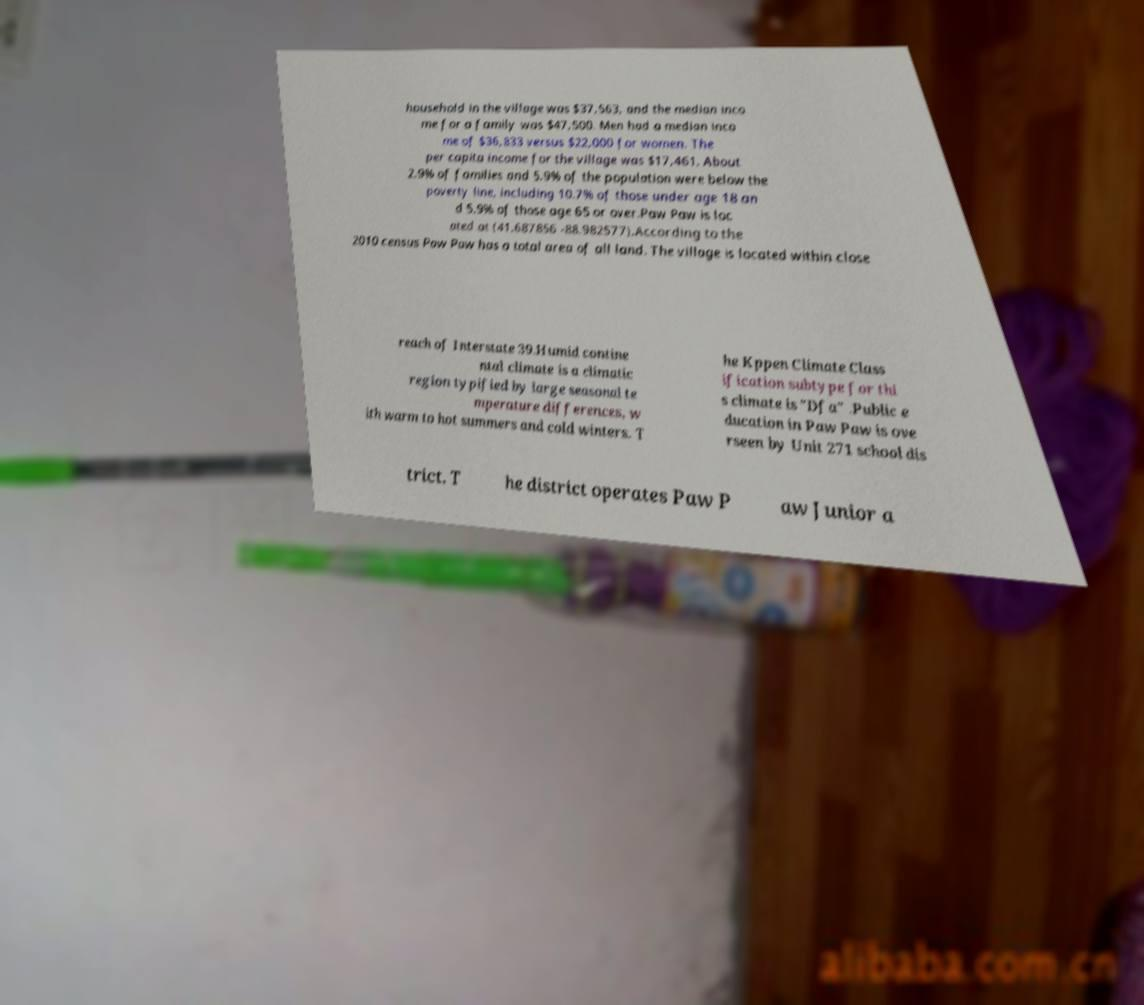What messages or text are displayed in this image? I need them in a readable, typed format. household in the village was $37,563, and the median inco me for a family was $47,500. Men had a median inco me of $36,833 versus $22,000 for women. The per capita income for the village was $17,461. About 2.9% of families and 5.9% of the population were below the poverty line, including 10.7% of those under age 18 an d 5.9% of those age 65 or over.Paw Paw is loc ated at (41.687856 -88.982577).According to the 2010 census Paw Paw has a total area of all land. The village is located within close reach of Interstate 39.Humid contine ntal climate is a climatic region typified by large seasonal te mperature differences, w ith warm to hot summers and cold winters. T he Kppen Climate Class ification subtype for thi s climate is "Dfa" .Public e ducation in Paw Paw is ove rseen by Unit 271 school dis trict. T he district operates Paw P aw Junior a 